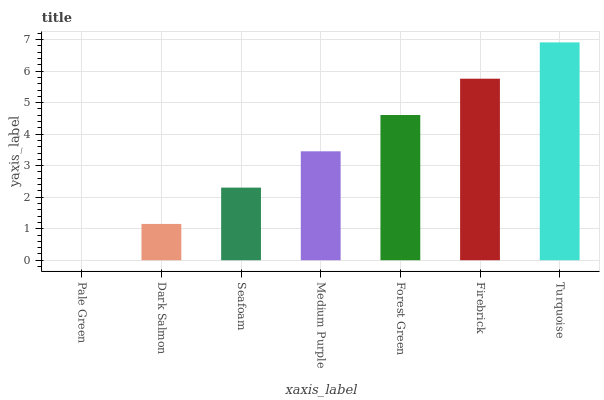Is Pale Green the minimum?
Answer yes or no. Yes. Is Turquoise the maximum?
Answer yes or no. Yes. Is Dark Salmon the minimum?
Answer yes or no. No. Is Dark Salmon the maximum?
Answer yes or no. No. Is Dark Salmon greater than Pale Green?
Answer yes or no. Yes. Is Pale Green less than Dark Salmon?
Answer yes or no. Yes. Is Pale Green greater than Dark Salmon?
Answer yes or no. No. Is Dark Salmon less than Pale Green?
Answer yes or no. No. Is Medium Purple the high median?
Answer yes or no. Yes. Is Medium Purple the low median?
Answer yes or no. Yes. Is Forest Green the high median?
Answer yes or no. No. Is Seafoam the low median?
Answer yes or no. No. 